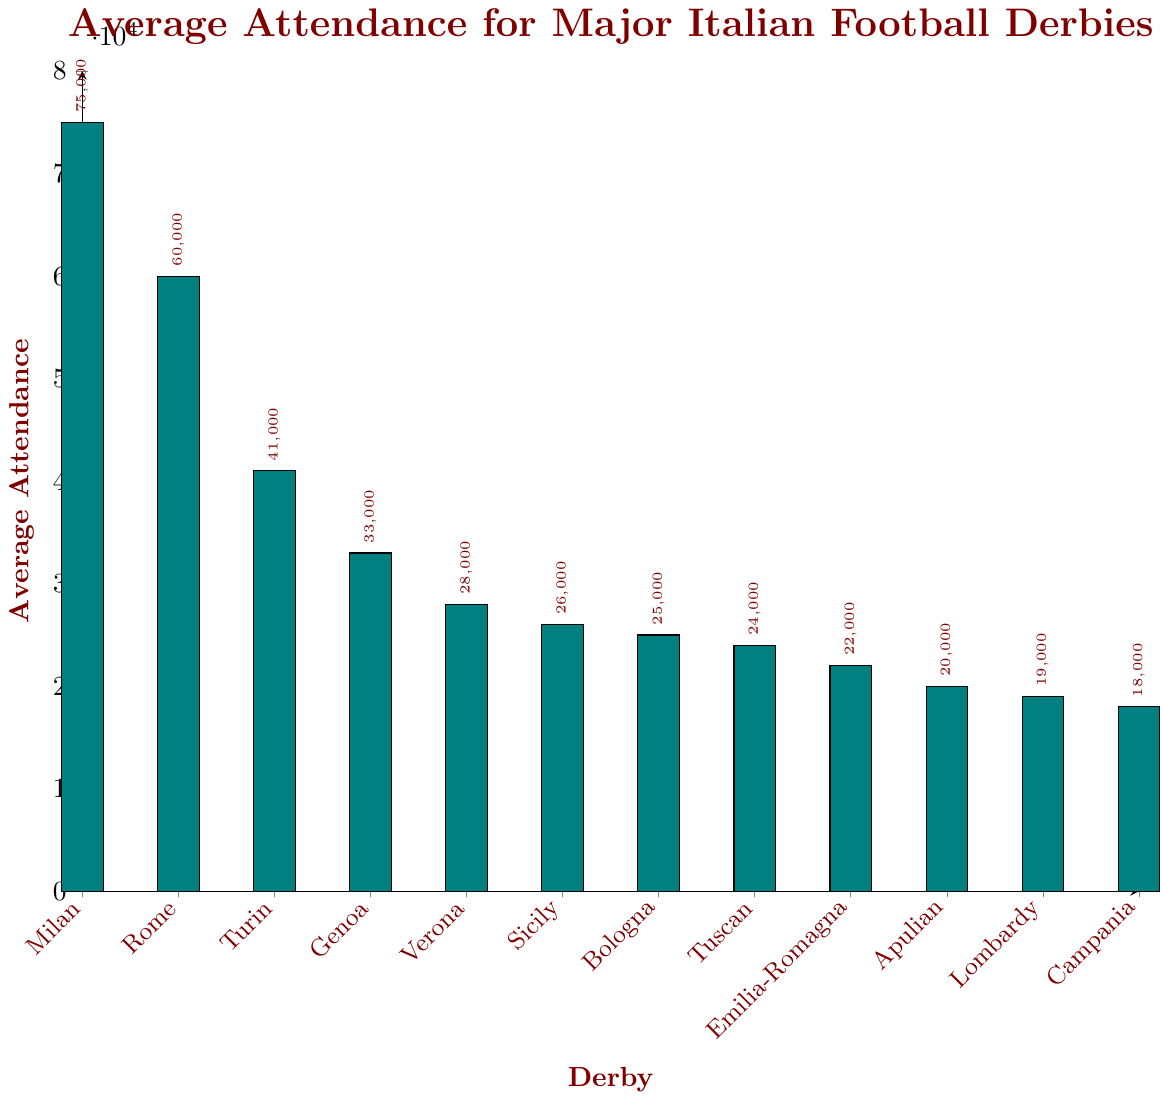Which derby has the highest average attendance? The highest average attendance can be seen from the tallest bar on the graph. The tallest bar corresponds to the Milan Derby (Inter vs AC Milan) with 75,000 spectators.
Answer: Milan Derby What is the attendance difference between the Rome Derby and the Campania Derby? The average attendance for the Rome Derby is 60,000 and for the Campania Derby is 18,000. The difference is calculated by subtracting the two values: 60,000 - 18,000 = 42,000.
Answer: 42,000 Which derby has an average attendance closest to 30,000? By looking at the heights of the bars, we find that the Verona Derby (Hellas Verona vs Chievo) has an average attendance of 28,000, which is closest to 30,000 among all derbies.
Answer: Verona Derby How many derbies have an attendance of less than 25,000? The bars corresponding to the derbies with attendances below 25,000 are counted. These are the Tuscan Derby, Emilia-Romagna Derby, Apulian Derby, Lombardy Derby, and Campania Derby, making a total of 5 derbies.
Answer: 5 What is the total average attendance for the top three derbies combined? The top three derbies in terms of average attendance are Milan Derby (75,000), Rome Derby (60,000), and Turin Derby (41,000). The total is calculated by summing these values: 75,000 + 60,000 + 41,000 = 176,000.
Answer: 176,000 Which derby has the second lowest average attendance? By examining the bar chart from the lowest to the second lowest, we see that the Campania Derby (Napoli vs Salernitana) is the lowest at 18,000, and the Lombardy Derby (Atalanta vs Brescia) is the second lowest at 19,000.
Answer: Lombardy Derby What is the average attendance for the derbies in the middle attendance range (between 25,000 to 35,000)? The derbies in this range are the Genoa Derby (33,000), Verona Derby (28,000), and Sicily Derby (26,000). The average is calculated by summing and dividing by the count: (33,000 + 28,000 + 26,000) / 3 = 87,000 / 3 = 29,000.
Answer: 29,000 By how much does the Bologna Derby lag behind the Rome Derby in terms of average attendance? The average attendance for the Bologna Derby is 25,000, whereas for the Rome Derby, it is 60,000. The lag is calculated as 60,000 - 25,000 = 35,000.
Answer: 35,000 What is the average attendance for the bottom four derbies? The bottom four derbies by average attendance are the Tuscan Derby (24,000), Emilia-Romagna Derby (22,000), Apulian Derby (20,000), and Campania Derby (18,000). The average is calculated as (24,000 + 22,000 + 20,000 + 18,000) / 4 = 84,000 / 4 = 21,000.
Answer: 21,000 